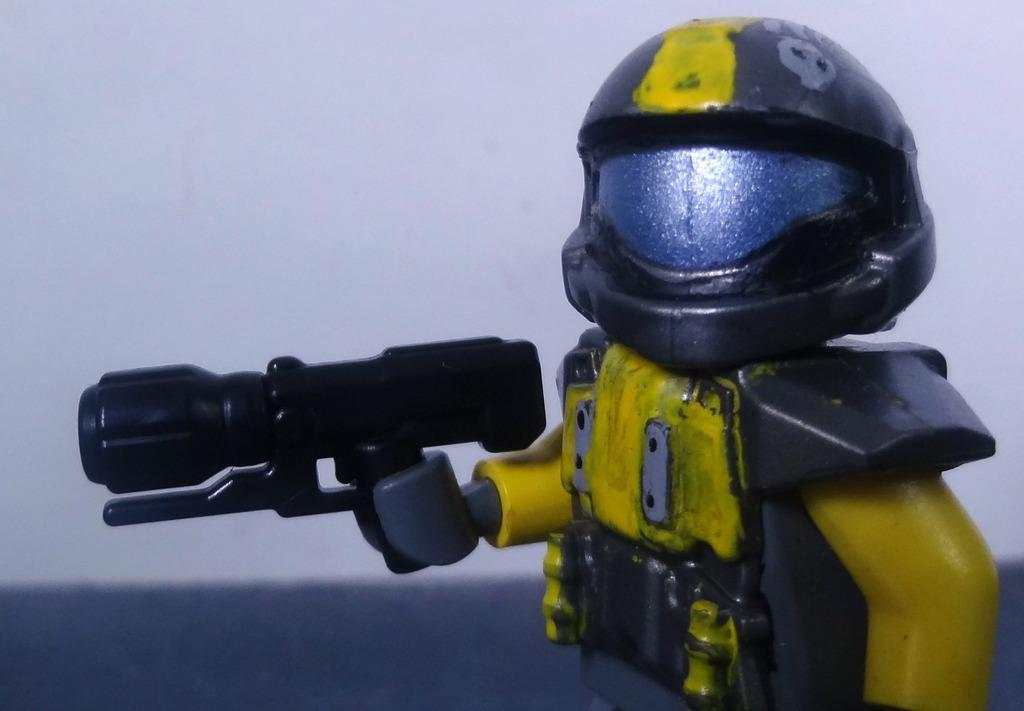What is located on the right side of the image? There is a robot on the right side of the image. What can be seen in the background of the image? There is a wall in the background of the image. What type of quince is being harvested in the field in the image? There is no field or quince present in the image; it features a robot and a wall in the background. 